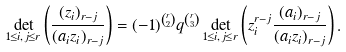Convert formula to latex. <formula><loc_0><loc_0><loc_500><loc_500>\det _ { 1 \leq i , j \leq r } \left ( \frac { ( z _ { i } ) _ { r - j } } { ( a _ { i } z _ { i } ) _ { r - j } } \right ) = ( - 1 ) ^ { \binom { r } { 2 } } q ^ { \binom { r } { 3 } } \det _ { 1 \leq i , j \leq r } \left ( z _ { i } ^ { r - j } \frac { ( a _ { i } ) _ { r - j } } { ( a _ { i } z _ { i } ) _ { r - j } } \right ) .</formula> 